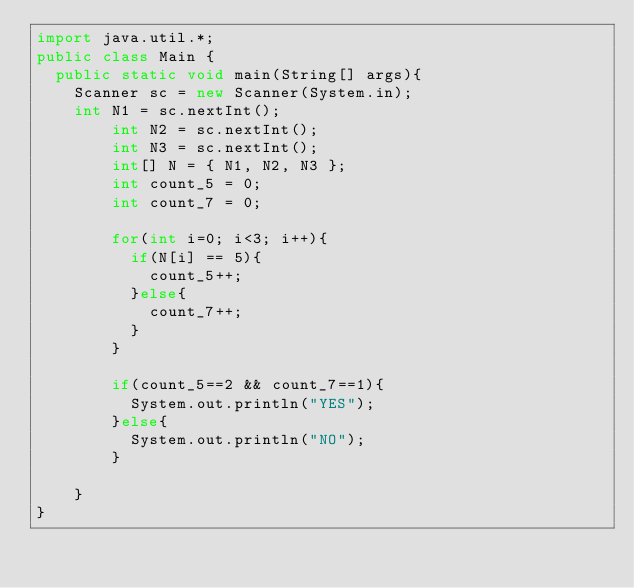Convert code to text. <code><loc_0><loc_0><loc_500><loc_500><_Java_>import java.util.*;
public class Main {
	public static void main(String[] args){
		Scanner sc = new Scanner(System.in);
		int N1 = sc.nextInt();
        int N2 = sc.nextInt();
        int N3 = sc.nextInt();
        int[] N = { N1, N2, N3 };
        int count_5 = 0;
        int count_7 = 0;
      
        for(int i=0; i<3; i++){
          if(N[i] == 5){
            count_5++;
          }else{
            count_7++;
          }
        }
      
        if(count_5==2 && count_7==1){
          System.out.println("YES");
        }else{
          System.out.println("NO");
        }
          
    }
}</code> 